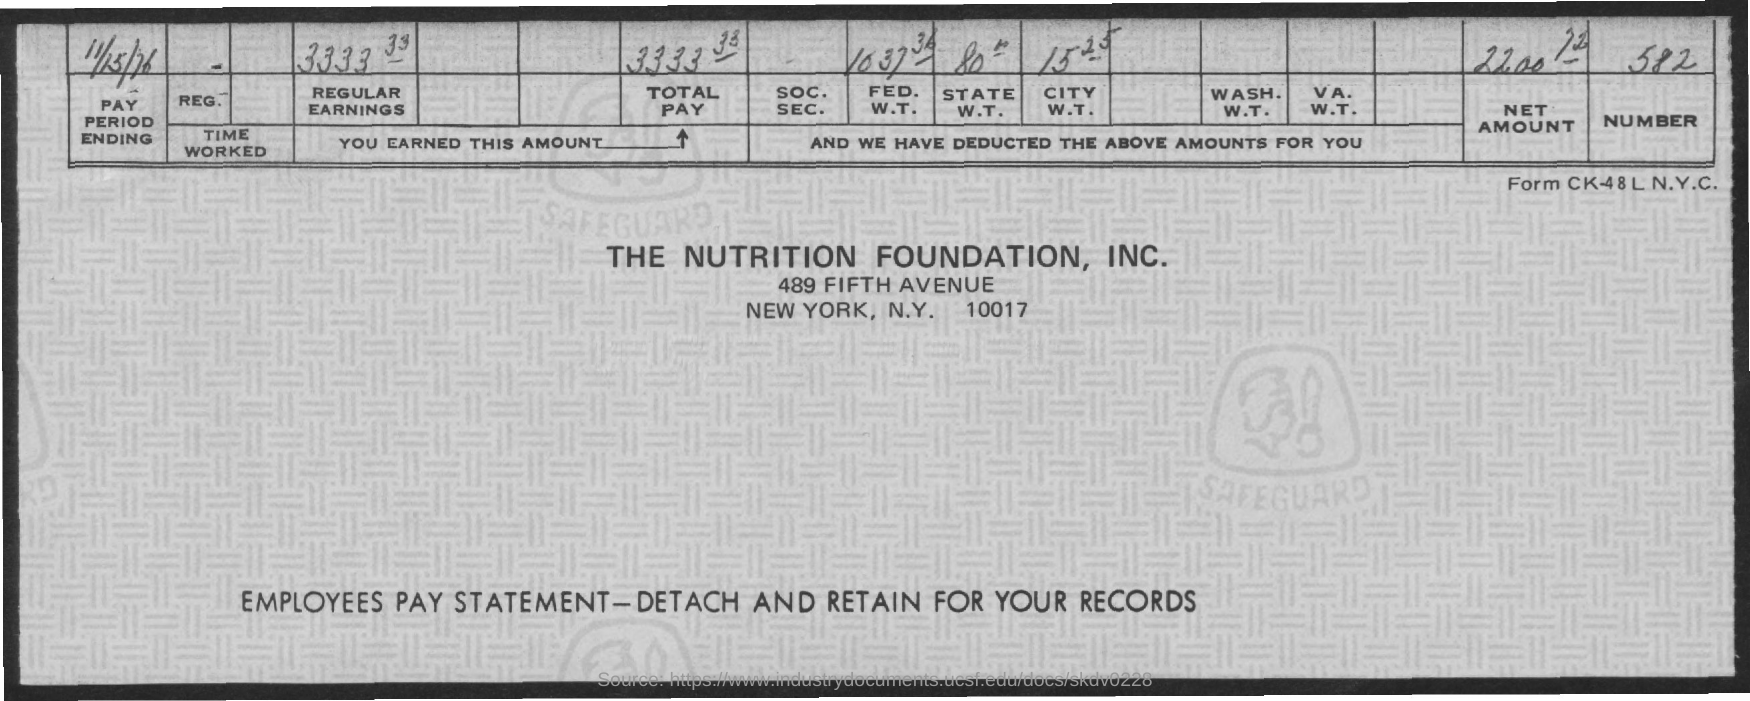Give some essential details in this illustration. The pay period ending date is November 15th, 1976. What is the NUMBER mentioned in the PAY STATEMENT?" the user asked. "It is 582," the agent replied. THE NUTRITION FOUNDATION, INC. is located in NEW YORK CITY. This document is the Employees Pay Statement. The ZIP code provided in the address is 10017. 